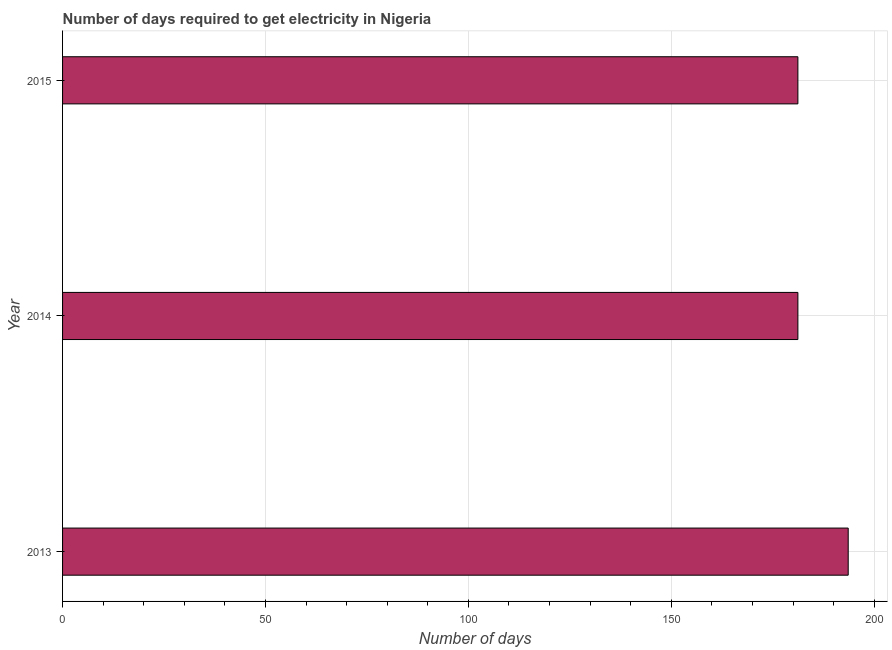What is the title of the graph?
Ensure brevity in your answer.  Number of days required to get electricity in Nigeria. What is the label or title of the X-axis?
Give a very brief answer. Number of days. What is the label or title of the Y-axis?
Give a very brief answer. Year. What is the time to get electricity in 2013?
Ensure brevity in your answer.  193.6. Across all years, what is the maximum time to get electricity?
Your answer should be very brief. 193.6. Across all years, what is the minimum time to get electricity?
Provide a succinct answer. 181.2. What is the sum of the time to get electricity?
Keep it short and to the point. 556. What is the average time to get electricity per year?
Keep it short and to the point. 185.33. What is the median time to get electricity?
Give a very brief answer. 181.2. Do a majority of the years between 2014 and 2013 (inclusive) have time to get electricity greater than 40 ?
Your answer should be very brief. No. What is the ratio of the time to get electricity in 2013 to that in 2015?
Keep it short and to the point. 1.07. Is the time to get electricity in 2014 less than that in 2015?
Provide a succinct answer. No. Is the difference between the time to get electricity in 2014 and 2015 greater than the difference between any two years?
Offer a terse response. No. What is the difference between the highest and the second highest time to get electricity?
Make the answer very short. 12.4. Is the sum of the time to get electricity in 2013 and 2015 greater than the maximum time to get electricity across all years?
Offer a terse response. Yes. What is the difference between the highest and the lowest time to get electricity?
Keep it short and to the point. 12.4. In how many years, is the time to get electricity greater than the average time to get electricity taken over all years?
Give a very brief answer. 1. How many bars are there?
Give a very brief answer. 3. What is the Number of days in 2013?
Your answer should be compact. 193.6. What is the Number of days of 2014?
Your answer should be compact. 181.2. What is the Number of days in 2015?
Your answer should be very brief. 181.2. What is the difference between the Number of days in 2014 and 2015?
Your response must be concise. 0. What is the ratio of the Number of days in 2013 to that in 2014?
Make the answer very short. 1.07. What is the ratio of the Number of days in 2013 to that in 2015?
Keep it short and to the point. 1.07. 